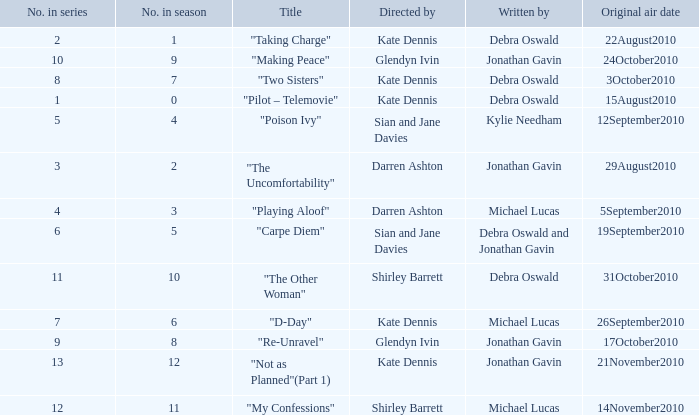When did "My Confessions" first air? 14November2010. 